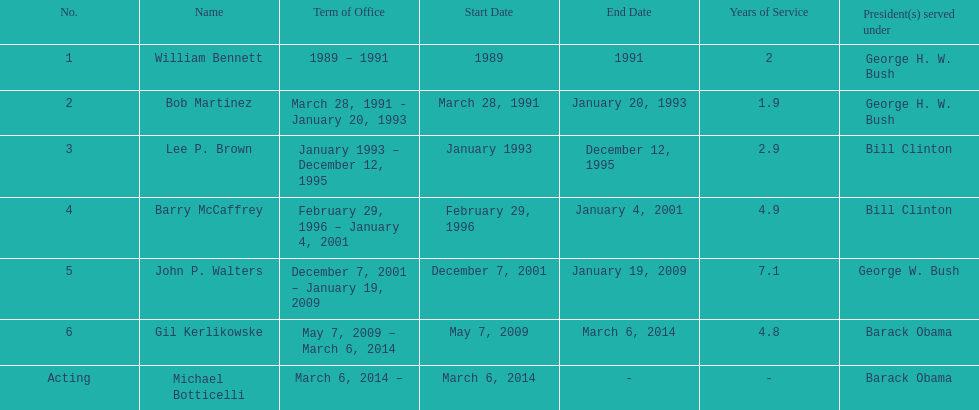What were the number of directors that stayed in office more than three years? 3. Would you mind parsing the complete table? {'header': ['No.', 'Name', 'Term of Office', 'Start Date', 'End Date', 'Years of Service', 'President(s) served under'], 'rows': [['1', 'William Bennett', '1989 – 1991', '1989', '1991', '2', 'George H. W. Bush'], ['2', 'Bob Martinez', 'March 28, 1991 - January 20, 1993', 'March 28, 1991', 'January 20, 1993', '1.9', 'George H. W. Bush'], ['3', 'Lee P. Brown', 'January 1993 – December 12, 1995', 'January 1993', 'December 12, 1995', '2.9', 'Bill Clinton'], ['4', 'Barry McCaffrey', 'February 29, 1996 – January 4, 2001', 'February 29, 1996', 'January 4, 2001', '4.9', 'Bill Clinton'], ['5', 'John P. Walters', 'December 7, 2001 – January 19, 2009', 'December 7, 2001', 'January 19, 2009', '7.1', 'George W. Bush'], ['6', 'Gil Kerlikowske', 'May 7, 2009 – March 6, 2014', 'May 7, 2009', 'March 6, 2014', '4.8', 'Barack Obama'], ['Acting', 'Michael Botticelli', 'March 6, 2014 –', 'March 6, 2014', '-', '-', 'Barack Obama']]} 